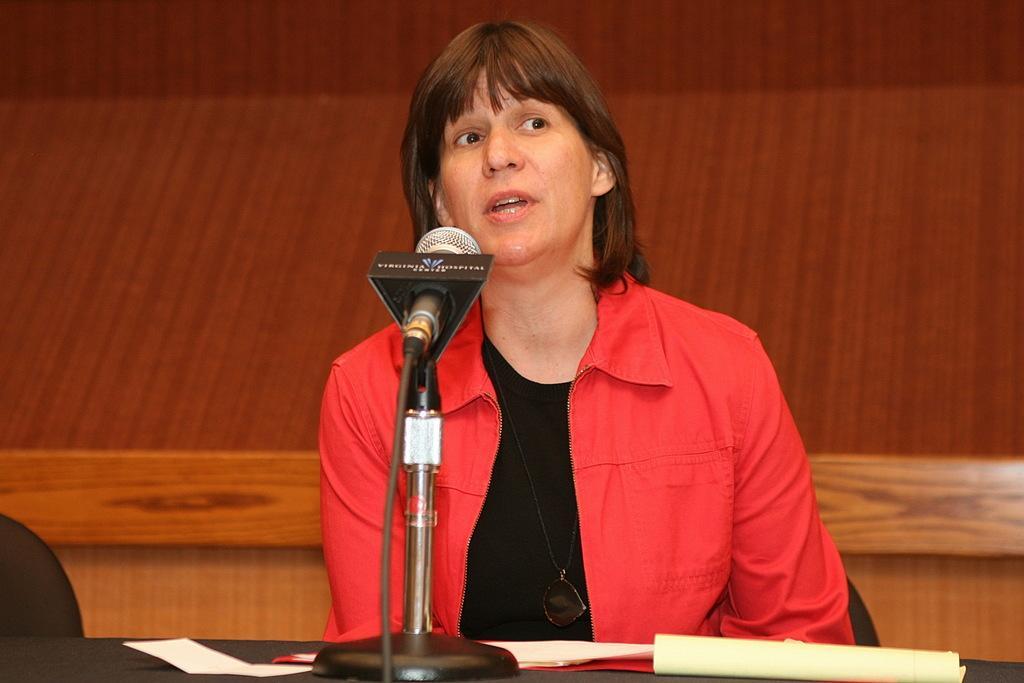How would you summarize this image in a sentence or two? There is a woman who is talking on the mike. She is in a red color jacket. This is table. On the table there are papers and there is a chair. On the background there is a wall. 